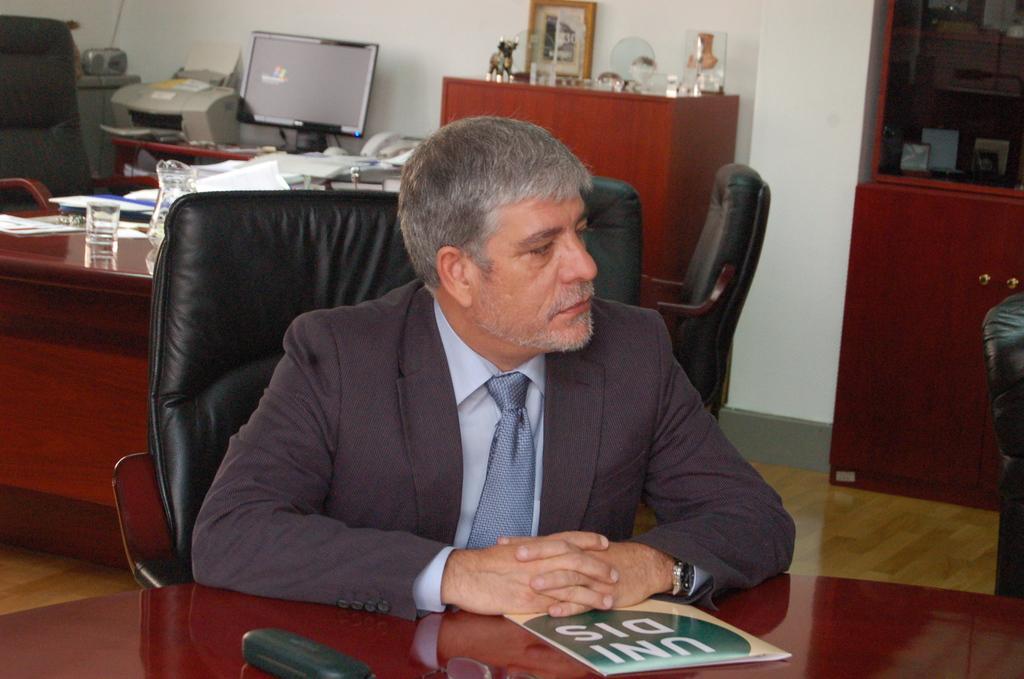In one or two sentences, can you explain what this image depicts? In this image I can see the person siting in-front few the table. On the table I can see the book and the pouch. In the background I can see the glass, jug, papers, system, an electronic device and the telephone. These are on the table. To the left I can see the chair. I can see the frame and few objects on the cupboard. I can also see the wall. 